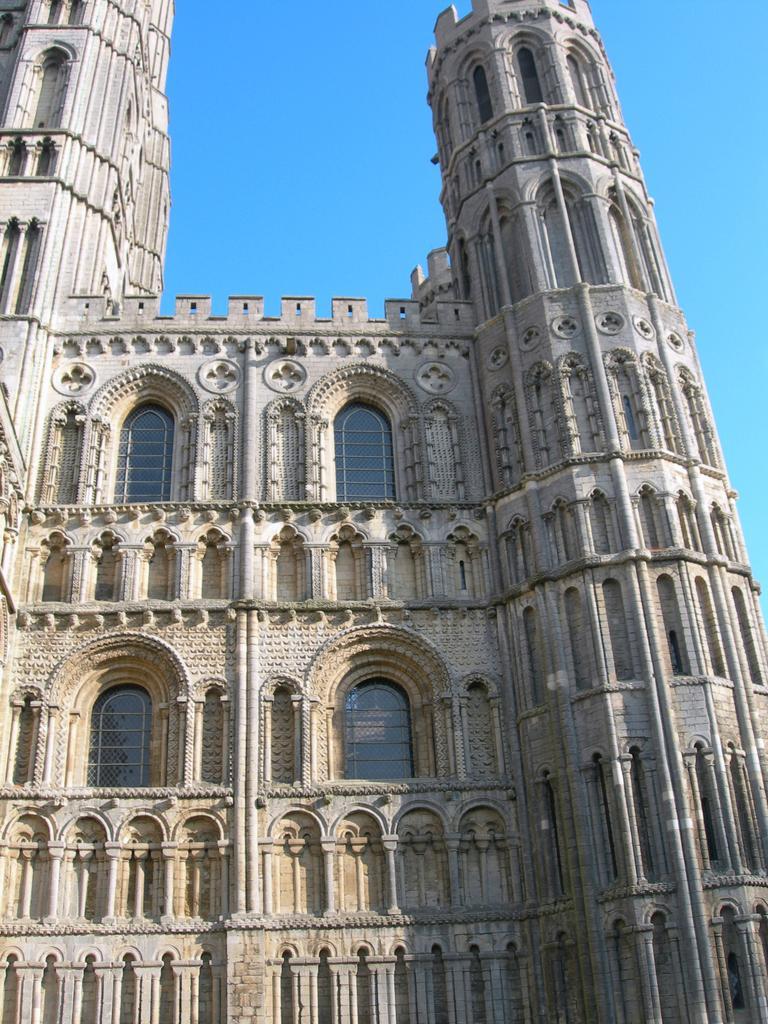How would you summarize this image in a sentence or two? In this image I can see the building. At the top I can see the sky. 